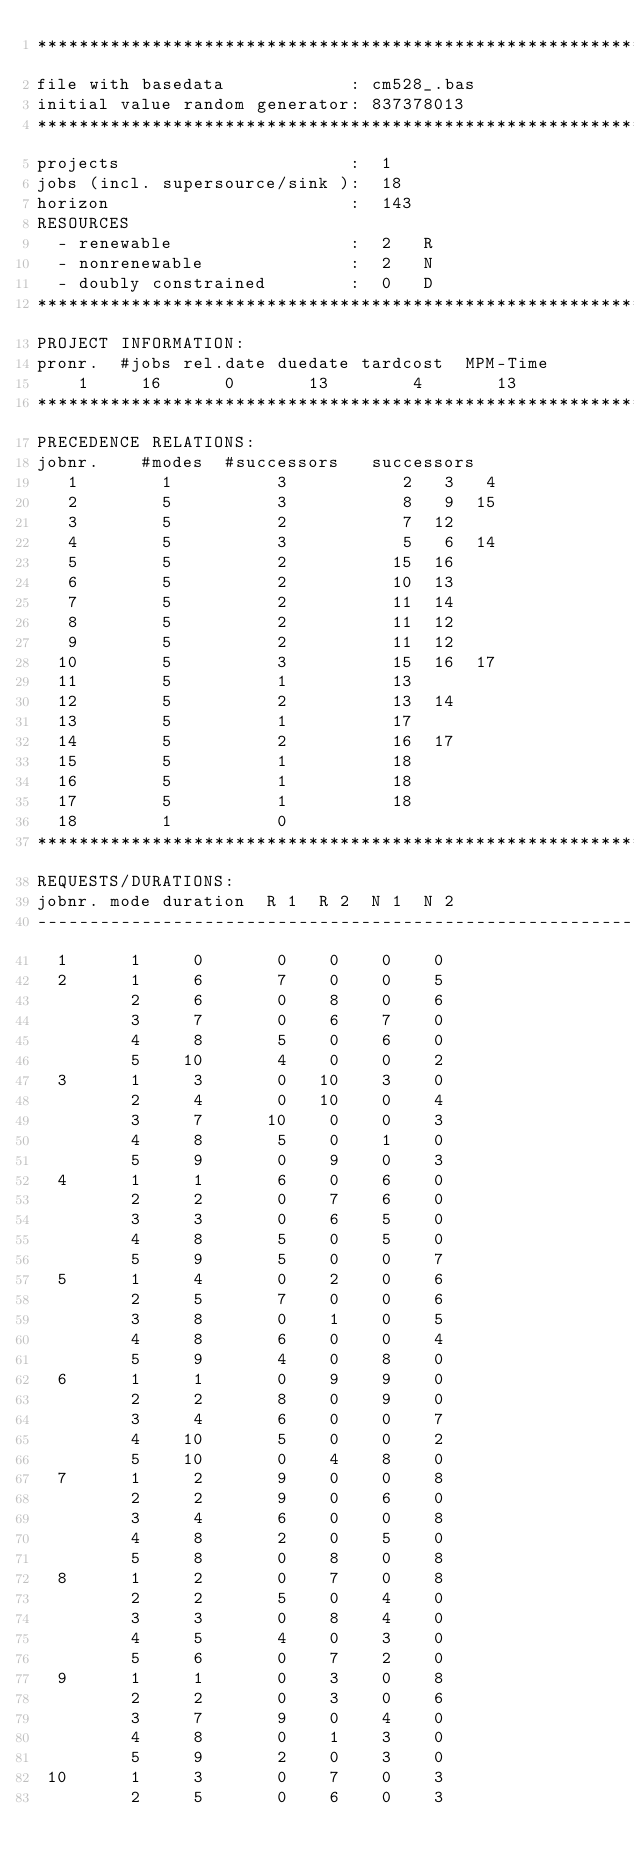Convert code to text. <code><loc_0><loc_0><loc_500><loc_500><_ObjectiveC_>************************************************************************
file with basedata            : cm528_.bas
initial value random generator: 837378013
************************************************************************
projects                      :  1
jobs (incl. supersource/sink ):  18
horizon                       :  143
RESOURCES
  - renewable                 :  2   R
  - nonrenewable              :  2   N
  - doubly constrained        :  0   D
************************************************************************
PROJECT INFORMATION:
pronr.  #jobs rel.date duedate tardcost  MPM-Time
    1     16      0       13        4       13
************************************************************************
PRECEDENCE RELATIONS:
jobnr.    #modes  #successors   successors
   1        1          3           2   3   4
   2        5          3           8   9  15
   3        5          2           7  12
   4        5          3           5   6  14
   5        5          2          15  16
   6        5          2          10  13
   7        5          2          11  14
   8        5          2          11  12
   9        5          2          11  12
  10        5          3          15  16  17
  11        5          1          13
  12        5          2          13  14
  13        5          1          17
  14        5          2          16  17
  15        5          1          18
  16        5          1          18
  17        5          1          18
  18        1          0        
************************************************************************
REQUESTS/DURATIONS:
jobnr. mode duration  R 1  R 2  N 1  N 2
------------------------------------------------------------------------
  1      1     0       0    0    0    0
  2      1     6       7    0    0    5
         2     6       0    8    0    6
         3     7       0    6    7    0
         4     8       5    0    6    0
         5    10       4    0    0    2
  3      1     3       0   10    3    0
         2     4       0   10    0    4
         3     7      10    0    0    3
         4     8       5    0    1    0
         5     9       0    9    0    3
  4      1     1       6    0    6    0
         2     2       0    7    6    0
         3     3       0    6    5    0
         4     8       5    0    5    0
         5     9       5    0    0    7
  5      1     4       0    2    0    6
         2     5       7    0    0    6
         3     8       0    1    0    5
         4     8       6    0    0    4
         5     9       4    0    8    0
  6      1     1       0    9    9    0
         2     2       8    0    9    0
         3     4       6    0    0    7
         4    10       5    0    0    2
         5    10       0    4    8    0
  7      1     2       9    0    0    8
         2     2       9    0    6    0
         3     4       6    0    0    8
         4     8       2    0    5    0
         5     8       0    8    0    8
  8      1     2       0    7    0    8
         2     2       5    0    4    0
         3     3       0    8    4    0
         4     5       4    0    3    0
         5     6       0    7    2    0
  9      1     1       0    3    0    8
         2     2       0    3    0    6
         3     7       9    0    4    0
         4     8       0    1    3    0
         5     9       2    0    3    0
 10      1     3       0    7    0    3
         2     5       0    6    0    3</code> 